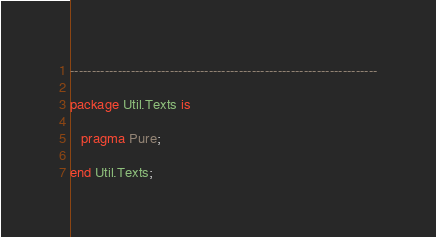<code> <loc_0><loc_0><loc_500><loc_500><_Ada_>-----------------------------------------------------------------------

package Util.Texts is

   pragma Pure;

end Util.Texts;
</code> 